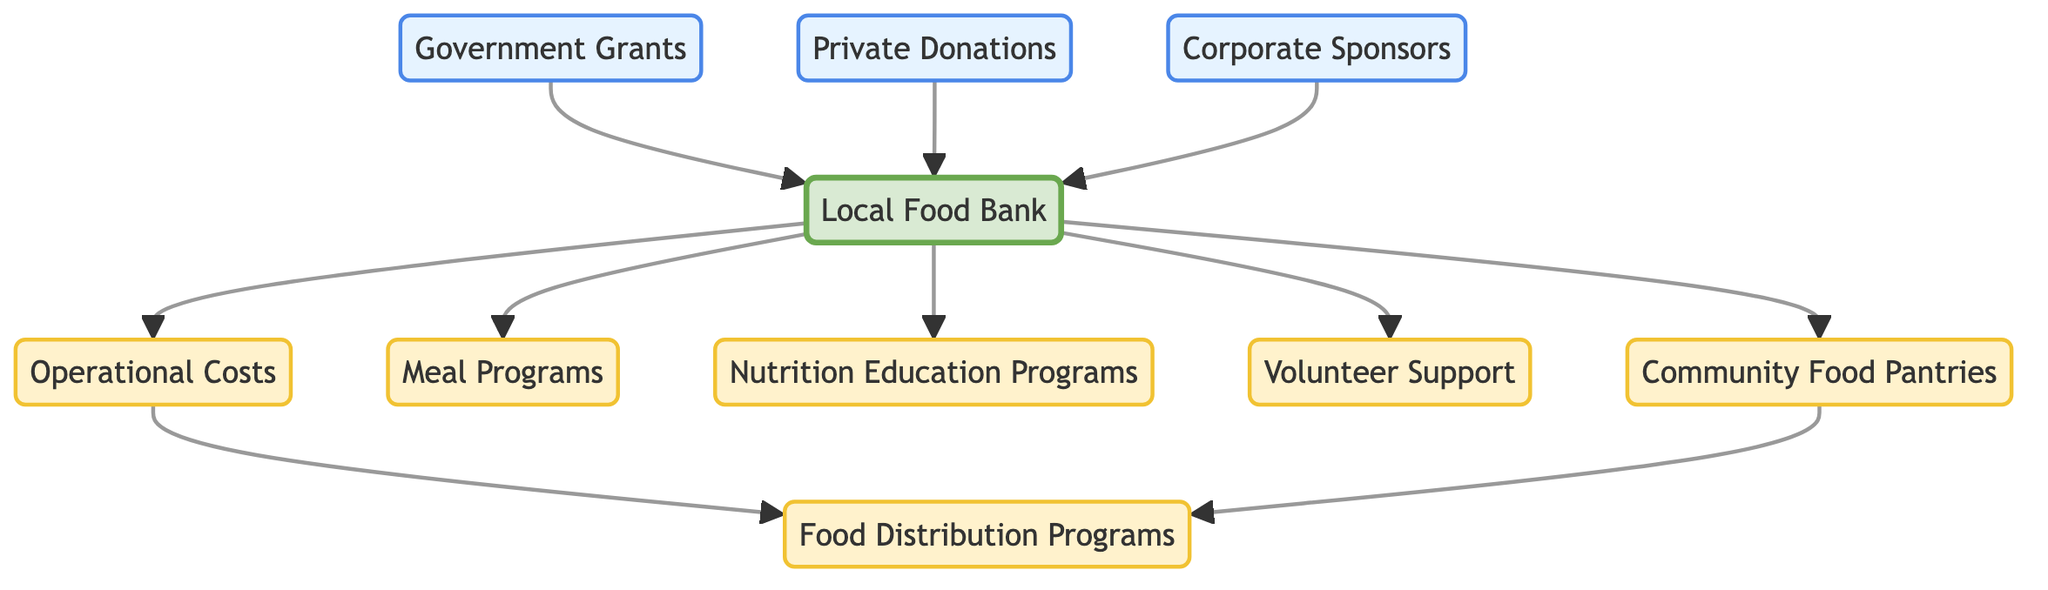What are the sources of funding for the Local Food Bank? The diagram shows three sources of funding directed to the Local Food Bank: Government Grants, Private Donations, and Corporate Sponsors. These nodes are depicted with arrows pointing to the Food Bank, indicating the flow of funds from each source.
Answer: Government Grants, Private Donations, Corporate Sponsors How many food assistance programs does the Local Food Bank support? The Local Food Bank supports four food assistance programs, which are represented by arrows directed from the Food Bank to the Community Food Pantries, Meal Programs, Nutrition Education Programs, and Volunteer Support. Each of these programs is a node connected to the Food Bank.
Answer: 4 Which node has the most incoming edges? The Local Food Bank has three incoming edges from Government Grants, Private Donations, and Corporate Sponsors. The other nodes in the diagram mostly serve as outputs or linkages from the Food Bank, making it the node with the most incoming edges overall.
Answer: Local Food Bank What is the relationship between Operational Costs and Food Distribution Programs? The Operational Costs node has a directed edge pointing toward the Food Distribution Programs node, indicating that operational costs contribute to the Food Distribution Programs. Therefore, understanding operational costs is crucial for the program's functioning.
Answer: Operational Costs contribute to Food Distribution Programs What is the total number of nodes in the diagram? The diagram consists of ten distinct nodes, including the Local Food Bank, sources of funding, and various programs. Counting all the unique nodes represented gives a total of ten.
Answer: 10 Which program utilizes volunteer support? The diagram indicates a direct connection from the Local Food Bank to Volunteer Support, suggesting that all programs receiving aid from the Food Bank might benefit from volunteer support. Each program can utilize volunteers to enhance their operations, though the connection is specifically highlighted from the Food Bank to Volunteers.
Answer: All programs utilize Volunteer Support How do Community Food Pantries contribute to Food Distribution? Community Food Pantries serve as a source node connected to Food Distribution Programs. The connection suggests that they play a critical role in facilitating the distribution of food to those in need, highlighting their importance in the food assistance network.
Answer: Community Food Pantries contribute to Food Distribution Programs What type of funding is not represented in the directed graph? The diagram does not include governmental subsidies or international aid as types of funding that could support the Local Food Bank. The only funding types represented are Government Grants, Private Donations, and Corporate Sponsors, so this highlights a potential area for additional funding sources.
Answer: Governmental subsidies or international aid 